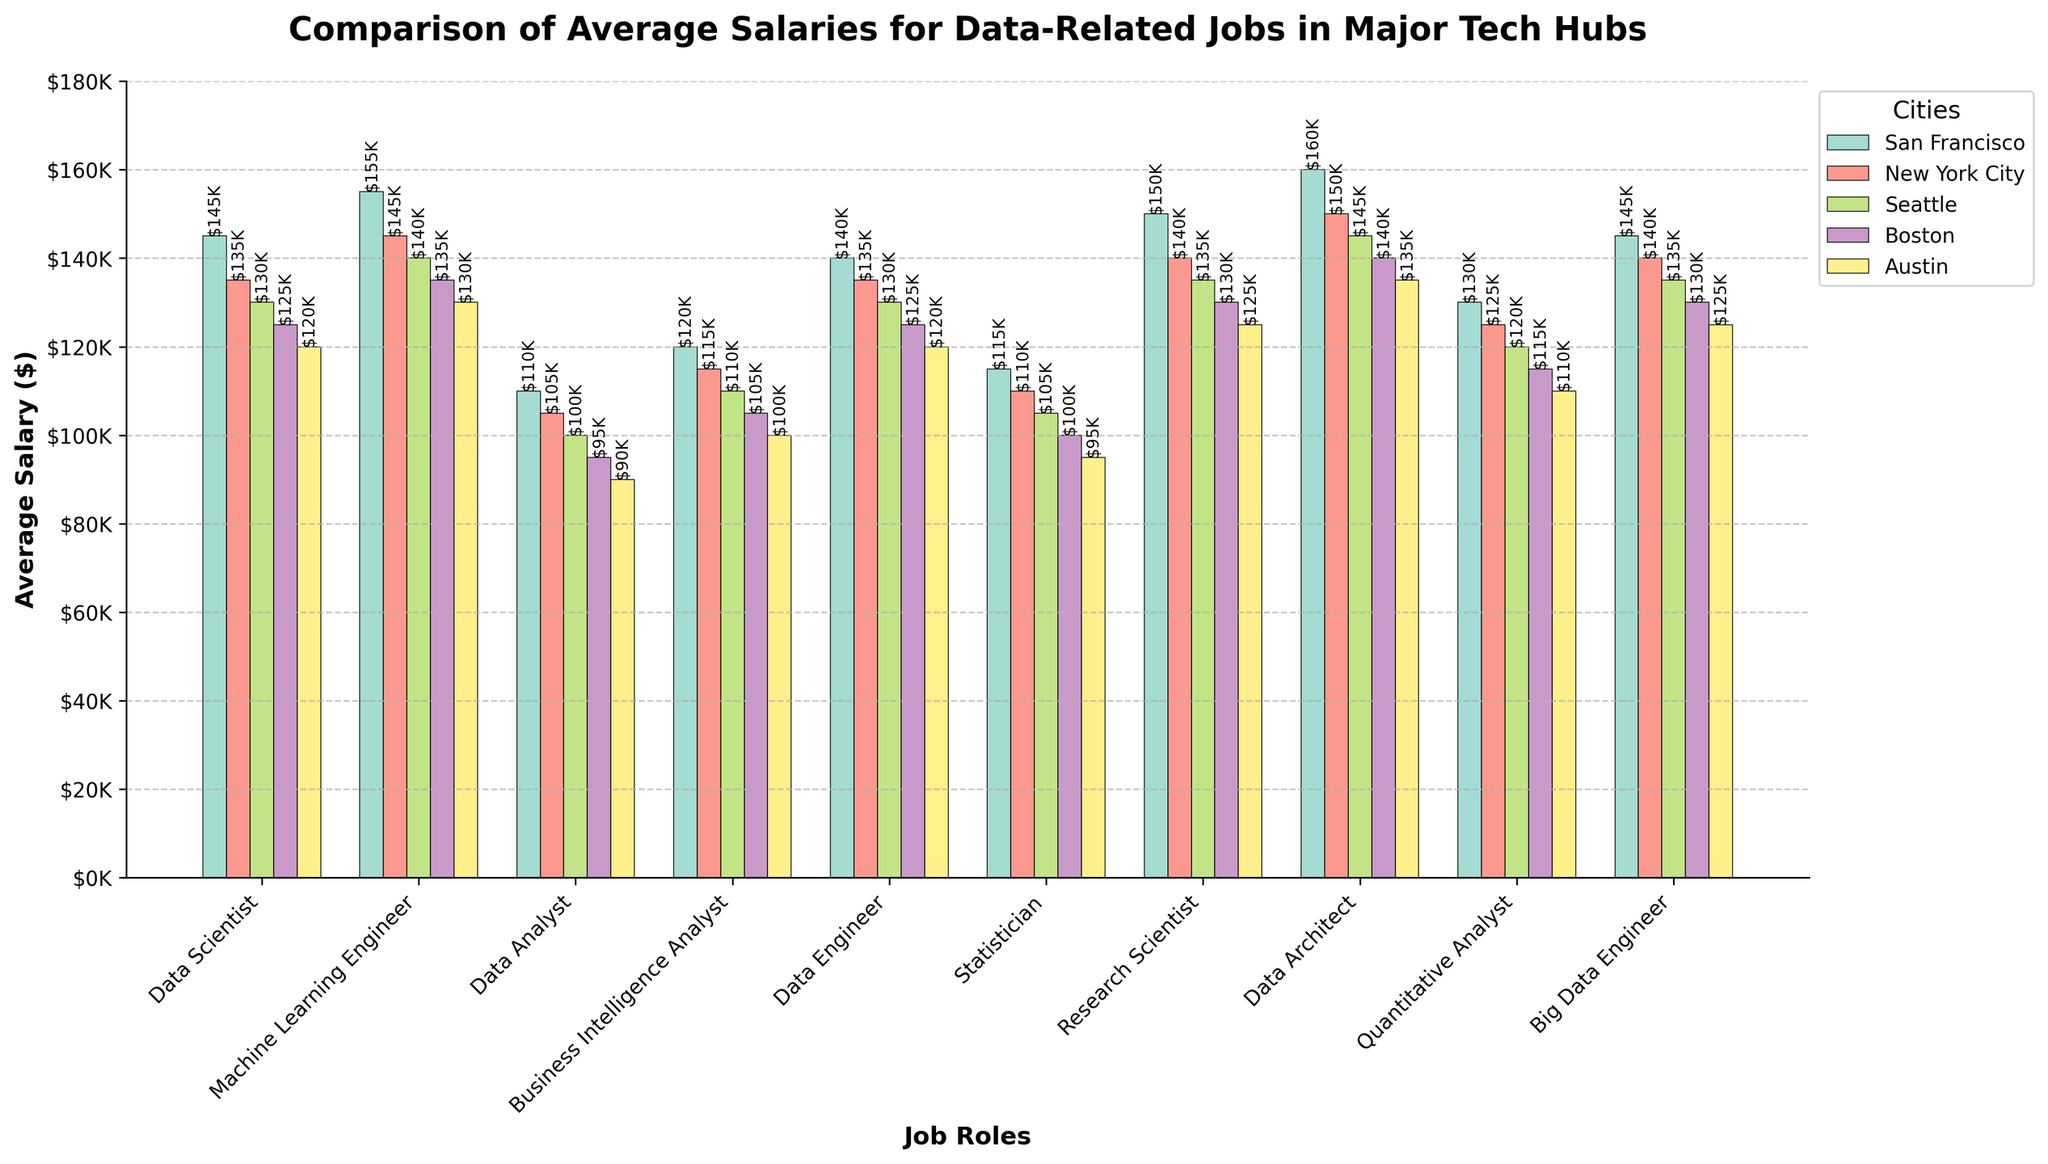What is the highest average salary among the job roles in San Francisco? The bars for San Francisco show the data architect role has the highest value.
Answer: $160K Which city offers the lowest average salary for a Data Analyst, and how much is it? Comparing the heights of the bars for Data Analyst across cities, Austin has the lowest.
Answer: $90K Between Machine Learning Engineer and Data Architect roles in New York City, which has a higher average salary and by how much? The heights of the bars for New York City show Data Architect is higher ($150K) compared to Machine Learning Engineer ($145K). The difference is $5K.
Answer: Data Architect, $5K Which job role sees the most significant drop in average salary from San Francisco to Austin? By examining the difference in heights between San Francisco and Austin, Data Architect drops from $160K to $135K, the largest drop of $25K.
Answer: Data Architect, $25K What is the average salary for a Statistician across all cities? Calculate the sum of Statistician salaries in all cities ($115K + $110K + $105K + $100K + $95K) and then divide by the number of cities (5).
Answer: $105K How does the average salary of a Data Scientist in Boston compare to that in Seattle? Checking the bars for Data Scientist, Boston's salary is $125K and Seattle's is $130K. The difference is -$5K.
Answer: $5K less in Boston Which job role has more consistent salaries across all cities? By visual inspection, the Data Engineer bars are relatively similar in height across different cities.
Answer: Data Engineer What is the combined average salary of a Business Intelligence Analyst in San Francisco and Austin? Sum the Business Intelligence Analyst salaries in San Francisco ($120K) and Austin ($100K) and divide by 2.
Answer: $110K For the role of Research Scientist, how much higher is the average salary in San Francisco compared to Boston? San Francisco has $150K and Boston has $130K, so the difference is $20K.
Answer: $20K What pattern can you observe about the salaries for Data Architect across all cities? The salaries for Data Architect decrease gradually from the highest in San Francisco ($160K) to the lowest in Austin ($135K).
Answer: Gradually decreasing 